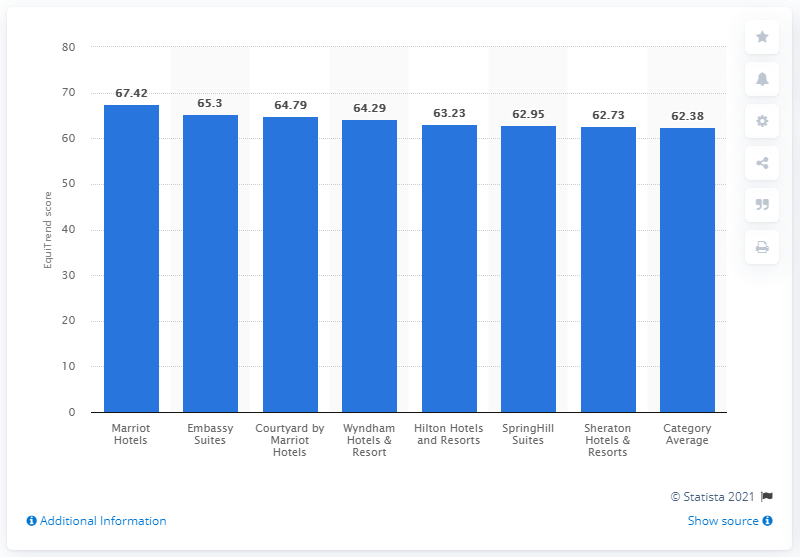Draw attention to some important aspects in this diagram. Marriott Suites received a EquiTrend score of 67.42 in 2012. 